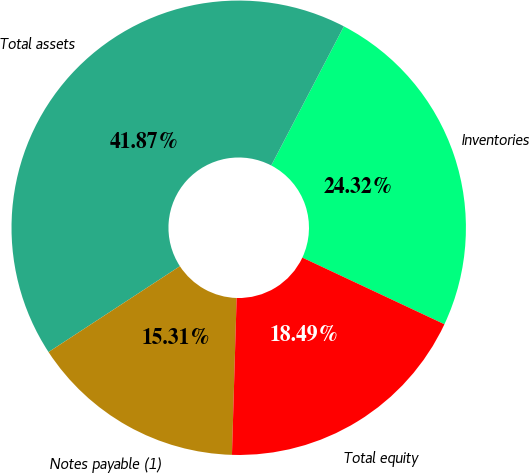Convert chart to OTSL. <chart><loc_0><loc_0><loc_500><loc_500><pie_chart><fcel>Inventories<fcel>Total assets<fcel>Notes payable (1)<fcel>Total equity<nl><fcel>24.32%<fcel>41.87%<fcel>15.31%<fcel>18.49%<nl></chart> 